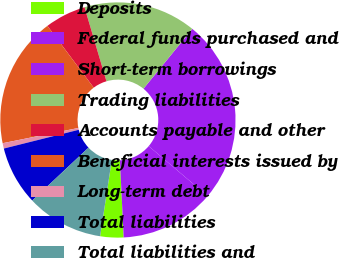<chart> <loc_0><loc_0><loc_500><loc_500><pie_chart><fcel>Deposits<fcel>Federal funds purchased and<fcel>Short-term borrowings<fcel>Trading liabilities<fcel>Accounts payable and other<fcel>Beneficial interests issued by<fcel>Long-term debt<fcel>Total liabilities<fcel>Total liabilities and<nl><fcel>3.2%<fcel>13.02%<fcel>25.3%<fcel>15.48%<fcel>5.65%<fcel>17.93%<fcel>0.74%<fcel>8.11%<fcel>10.57%<nl></chart> 